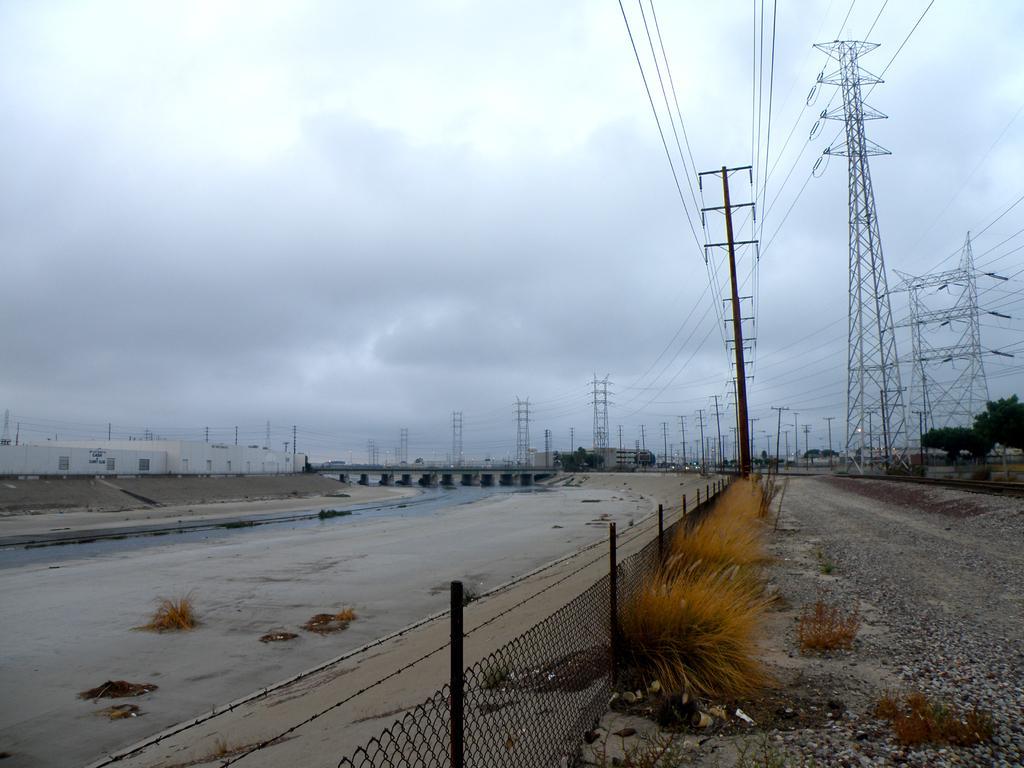How would you summarize this image in a sentence or two? In this image there are grass, plants, trees, cell towers, poles, water, bridge, buildings,fence, sky. 